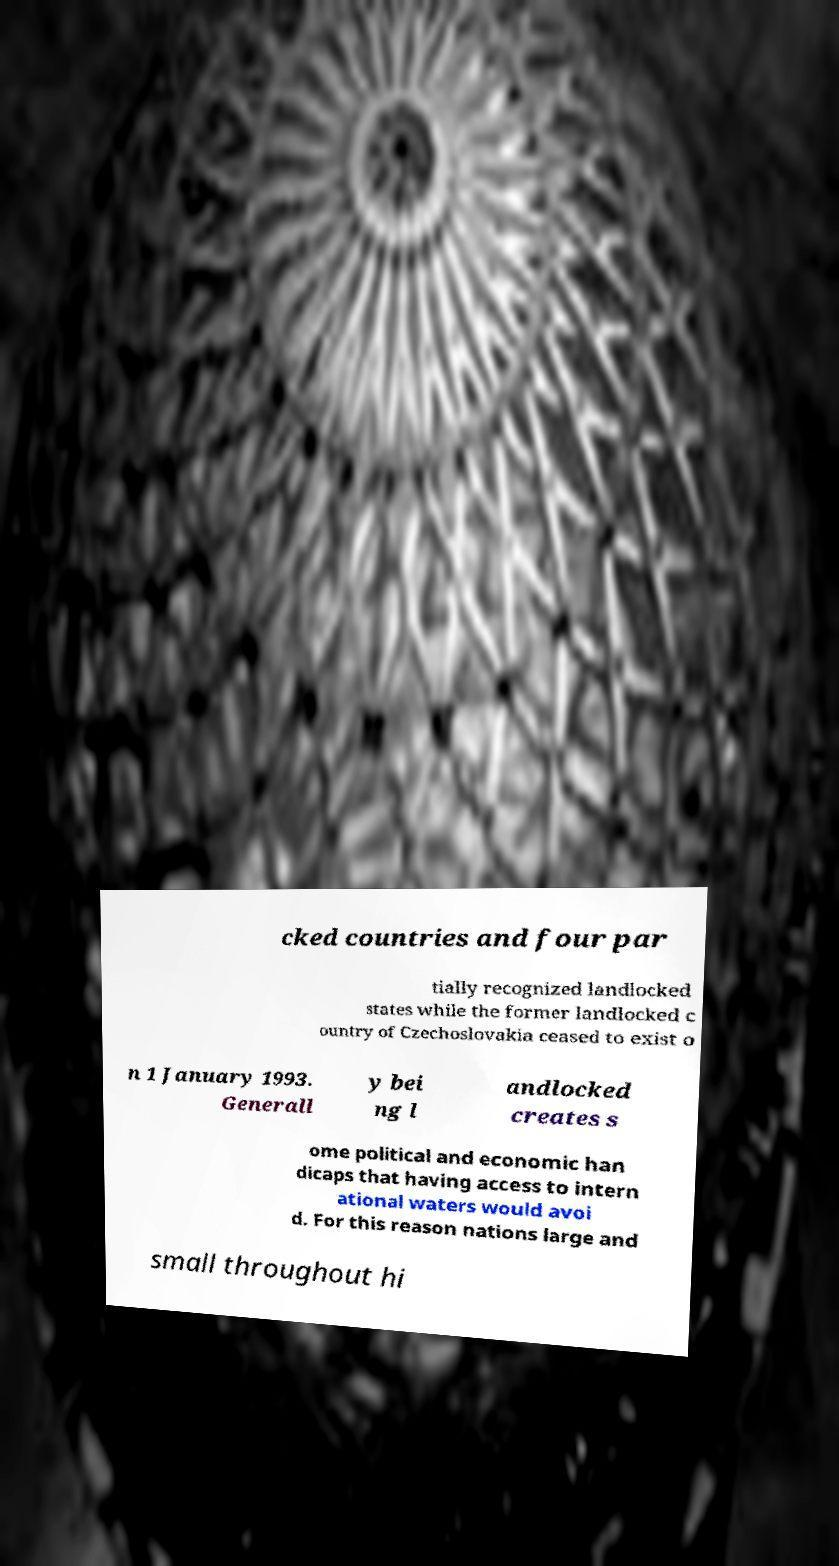Please read and relay the text visible in this image. What does it say? cked countries and four par tially recognized landlocked states while the former landlocked c ountry of Czechoslovakia ceased to exist o n 1 January 1993. Generall y bei ng l andlocked creates s ome political and economic han dicaps that having access to intern ational waters would avoi d. For this reason nations large and small throughout hi 